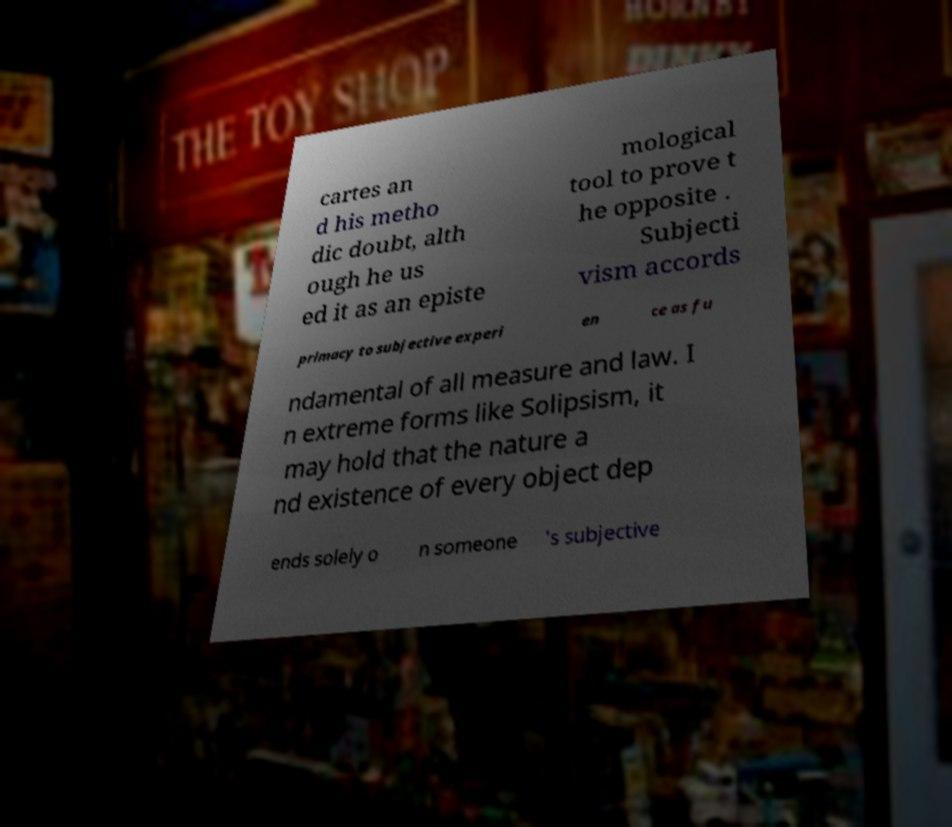Please identify and transcribe the text found in this image. cartes an d his metho dic doubt, alth ough he us ed it as an episte mological tool to prove t he opposite . Subjecti vism accords primacy to subjective experi en ce as fu ndamental of all measure and law. I n extreme forms like Solipsism, it may hold that the nature a nd existence of every object dep ends solely o n someone 's subjective 